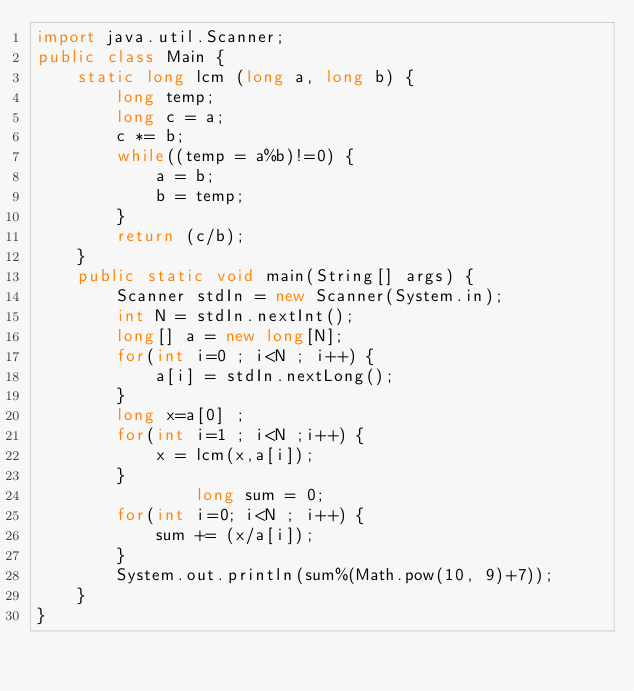<code> <loc_0><loc_0><loc_500><loc_500><_Java_>import java.util.Scanner;
public class Main {
	static long lcm (long a, long b) {
		long temp;
		long c = a;
		c *= b;
		while((temp = a%b)!=0) {
			a = b;
			b = temp;
		}
		return (c/b);
	}
	public static void main(String[] args) {
		Scanner stdIn = new Scanner(System.in);
		int N = stdIn.nextInt();
		long[] a = new long[N];
		for(int i=0 ; i<N ; i++) {
			a[i] = stdIn.nextLong();
		}
		long x=a[0] ;
		for(int i=1 ; i<N ;i++) {
			x = lcm(x,a[i]);
		}
				long sum = 0;
		for(int i=0; i<N ; i++) {
			sum += (x/a[i]);
		}
		System.out.println(sum%(Math.pow(10, 9)+7));
	}
}
</code> 